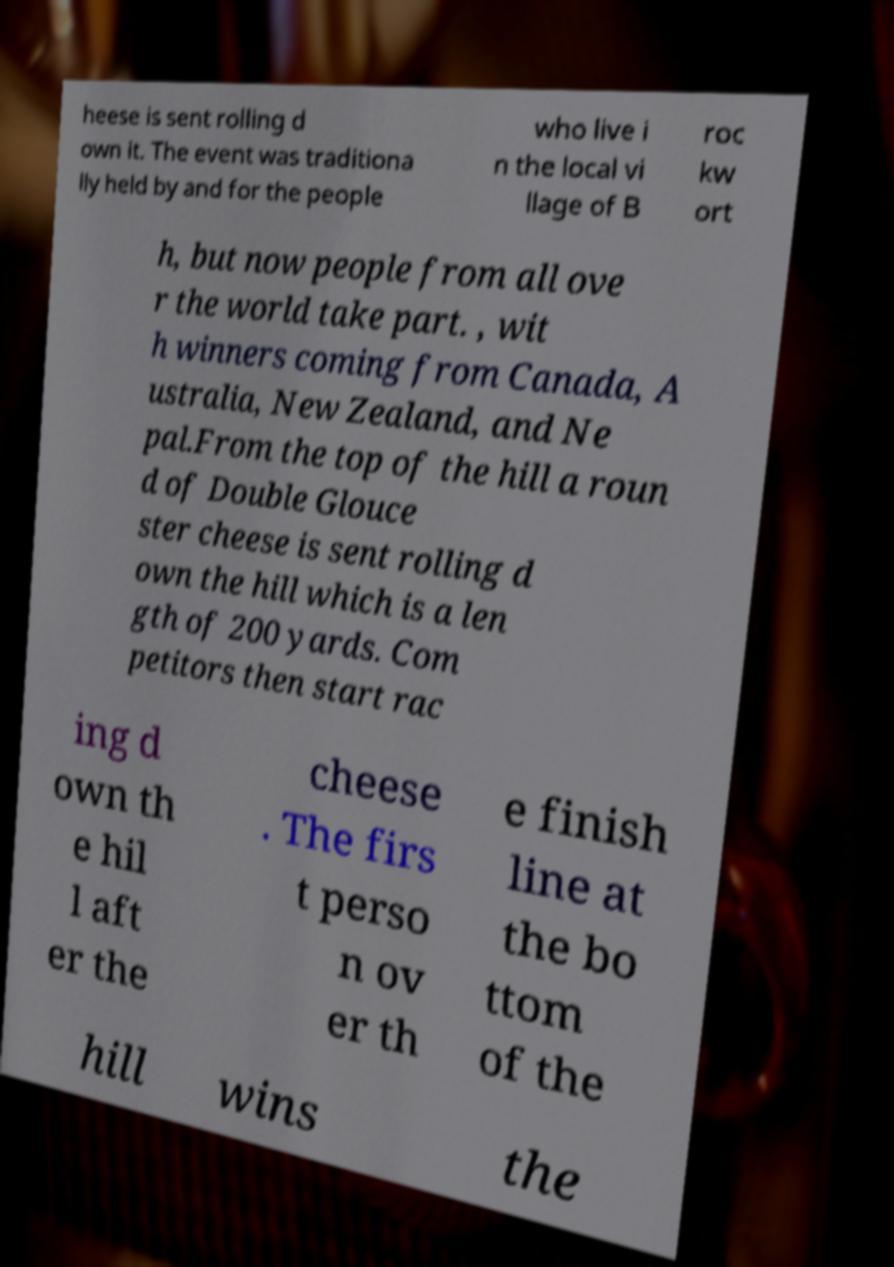For documentation purposes, I need the text within this image transcribed. Could you provide that? heese is sent rolling d own it. The event was traditiona lly held by and for the people who live i n the local vi llage of B roc kw ort h, but now people from all ove r the world take part. , wit h winners coming from Canada, A ustralia, New Zealand, and Ne pal.From the top of the hill a roun d of Double Glouce ster cheese is sent rolling d own the hill which is a len gth of 200 yards. Com petitors then start rac ing d own th e hil l aft er the cheese . The firs t perso n ov er th e finish line at the bo ttom of the hill wins the 